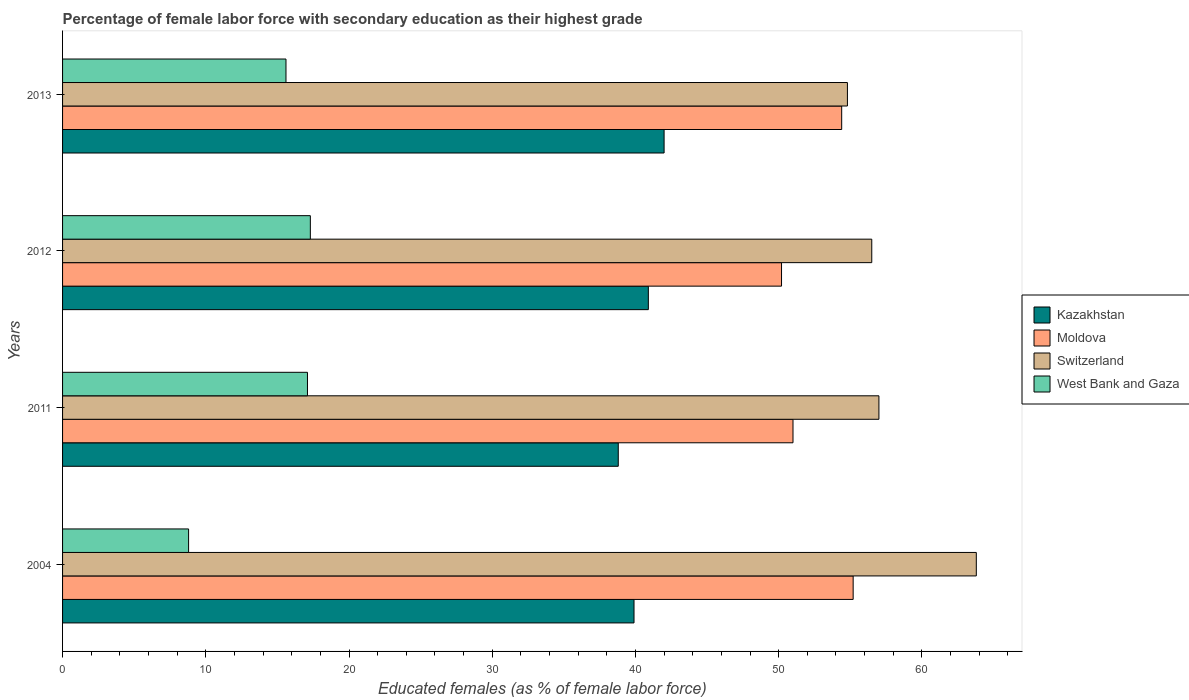What is the label of the 1st group of bars from the top?
Your answer should be compact. 2013. In how many cases, is the number of bars for a given year not equal to the number of legend labels?
Give a very brief answer. 0. What is the percentage of female labor force with secondary education in Moldova in 2004?
Ensure brevity in your answer.  55.2. Across all years, what is the maximum percentage of female labor force with secondary education in West Bank and Gaza?
Offer a very short reply. 17.3. Across all years, what is the minimum percentage of female labor force with secondary education in West Bank and Gaza?
Ensure brevity in your answer.  8.8. In which year was the percentage of female labor force with secondary education in Moldova maximum?
Give a very brief answer. 2004. What is the total percentage of female labor force with secondary education in West Bank and Gaza in the graph?
Keep it short and to the point. 58.8. What is the difference between the percentage of female labor force with secondary education in Moldova in 2004 and that in 2012?
Offer a terse response. 5. What is the difference between the percentage of female labor force with secondary education in Switzerland in 2004 and the percentage of female labor force with secondary education in Moldova in 2012?
Offer a terse response. 13.6. What is the average percentage of female labor force with secondary education in Moldova per year?
Give a very brief answer. 52.7. In the year 2012, what is the difference between the percentage of female labor force with secondary education in Switzerland and percentage of female labor force with secondary education in Kazakhstan?
Your answer should be compact. 15.6. In how many years, is the percentage of female labor force with secondary education in Kazakhstan greater than 4 %?
Make the answer very short. 4. What is the ratio of the percentage of female labor force with secondary education in Moldova in 2011 to that in 2012?
Your response must be concise. 1.02. Is the percentage of female labor force with secondary education in Kazakhstan in 2004 less than that in 2013?
Provide a short and direct response. Yes. What is the difference between the highest and the second highest percentage of female labor force with secondary education in Kazakhstan?
Ensure brevity in your answer.  1.1. What is the difference between the highest and the lowest percentage of female labor force with secondary education in West Bank and Gaza?
Your answer should be very brief. 8.5. Is it the case that in every year, the sum of the percentage of female labor force with secondary education in West Bank and Gaza and percentage of female labor force with secondary education in Kazakhstan is greater than the sum of percentage of female labor force with secondary education in Switzerland and percentage of female labor force with secondary education in Moldova?
Give a very brief answer. No. What does the 4th bar from the top in 2012 represents?
Offer a terse response. Kazakhstan. What does the 4th bar from the bottom in 2011 represents?
Provide a succinct answer. West Bank and Gaza. How many bars are there?
Your response must be concise. 16. How many years are there in the graph?
Your response must be concise. 4. Does the graph contain any zero values?
Provide a succinct answer. No. Does the graph contain grids?
Your response must be concise. No. Where does the legend appear in the graph?
Give a very brief answer. Center right. How many legend labels are there?
Provide a succinct answer. 4. How are the legend labels stacked?
Your answer should be very brief. Vertical. What is the title of the graph?
Offer a terse response. Percentage of female labor force with secondary education as their highest grade. What is the label or title of the X-axis?
Make the answer very short. Educated females (as % of female labor force). What is the Educated females (as % of female labor force) of Kazakhstan in 2004?
Your answer should be compact. 39.9. What is the Educated females (as % of female labor force) in Moldova in 2004?
Make the answer very short. 55.2. What is the Educated females (as % of female labor force) in Switzerland in 2004?
Your response must be concise. 63.8. What is the Educated females (as % of female labor force) in West Bank and Gaza in 2004?
Your answer should be compact. 8.8. What is the Educated females (as % of female labor force) in Kazakhstan in 2011?
Give a very brief answer. 38.8. What is the Educated females (as % of female labor force) of Switzerland in 2011?
Offer a terse response. 57. What is the Educated females (as % of female labor force) in West Bank and Gaza in 2011?
Provide a succinct answer. 17.1. What is the Educated females (as % of female labor force) in Kazakhstan in 2012?
Offer a very short reply. 40.9. What is the Educated females (as % of female labor force) in Moldova in 2012?
Give a very brief answer. 50.2. What is the Educated females (as % of female labor force) of Switzerland in 2012?
Ensure brevity in your answer.  56.5. What is the Educated females (as % of female labor force) in West Bank and Gaza in 2012?
Offer a terse response. 17.3. What is the Educated females (as % of female labor force) in Kazakhstan in 2013?
Your answer should be very brief. 42. What is the Educated females (as % of female labor force) of Moldova in 2013?
Offer a very short reply. 54.4. What is the Educated females (as % of female labor force) in Switzerland in 2013?
Your answer should be compact. 54.8. What is the Educated females (as % of female labor force) in West Bank and Gaza in 2013?
Ensure brevity in your answer.  15.6. Across all years, what is the maximum Educated females (as % of female labor force) in Moldova?
Offer a very short reply. 55.2. Across all years, what is the maximum Educated females (as % of female labor force) of Switzerland?
Offer a very short reply. 63.8. Across all years, what is the maximum Educated females (as % of female labor force) in West Bank and Gaza?
Offer a terse response. 17.3. Across all years, what is the minimum Educated females (as % of female labor force) in Kazakhstan?
Offer a terse response. 38.8. Across all years, what is the minimum Educated females (as % of female labor force) of Moldova?
Provide a short and direct response. 50.2. Across all years, what is the minimum Educated females (as % of female labor force) of Switzerland?
Your response must be concise. 54.8. Across all years, what is the minimum Educated females (as % of female labor force) of West Bank and Gaza?
Provide a succinct answer. 8.8. What is the total Educated females (as % of female labor force) in Kazakhstan in the graph?
Provide a short and direct response. 161.6. What is the total Educated females (as % of female labor force) of Moldova in the graph?
Your answer should be very brief. 210.8. What is the total Educated females (as % of female labor force) in Switzerland in the graph?
Your response must be concise. 232.1. What is the total Educated females (as % of female labor force) of West Bank and Gaza in the graph?
Your answer should be compact. 58.8. What is the difference between the Educated females (as % of female labor force) in Kazakhstan in 2004 and that in 2011?
Keep it short and to the point. 1.1. What is the difference between the Educated females (as % of female labor force) of Switzerland in 2004 and that in 2011?
Give a very brief answer. 6.8. What is the difference between the Educated females (as % of female labor force) of Moldova in 2004 and that in 2012?
Keep it short and to the point. 5. What is the difference between the Educated females (as % of female labor force) in Switzerland in 2004 and that in 2012?
Offer a terse response. 7.3. What is the difference between the Educated females (as % of female labor force) of Kazakhstan in 2004 and that in 2013?
Provide a succinct answer. -2.1. What is the difference between the Educated females (as % of female labor force) in Switzerland in 2004 and that in 2013?
Give a very brief answer. 9. What is the difference between the Educated females (as % of female labor force) in West Bank and Gaza in 2004 and that in 2013?
Offer a terse response. -6.8. What is the difference between the Educated females (as % of female labor force) in Kazakhstan in 2011 and that in 2012?
Provide a succinct answer. -2.1. What is the difference between the Educated females (as % of female labor force) of Moldova in 2011 and that in 2012?
Provide a succinct answer. 0.8. What is the difference between the Educated females (as % of female labor force) of Switzerland in 2011 and that in 2012?
Keep it short and to the point. 0.5. What is the difference between the Educated females (as % of female labor force) in West Bank and Gaza in 2011 and that in 2012?
Your answer should be very brief. -0.2. What is the difference between the Educated females (as % of female labor force) in Kazakhstan in 2012 and that in 2013?
Your answer should be compact. -1.1. What is the difference between the Educated females (as % of female labor force) in Moldova in 2012 and that in 2013?
Give a very brief answer. -4.2. What is the difference between the Educated females (as % of female labor force) of Switzerland in 2012 and that in 2013?
Provide a succinct answer. 1.7. What is the difference between the Educated females (as % of female labor force) of Kazakhstan in 2004 and the Educated females (as % of female labor force) of Moldova in 2011?
Offer a terse response. -11.1. What is the difference between the Educated females (as % of female labor force) of Kazakhstan in 2004 and the Educated females (as % of female labor force) of Switzerland in 2011?
Provide a short and direct response. -17.1. What is the difference between the Educated females (as % of female labor force) of Kazakhstan in 2004 and the Educated females (as % of female labor force) of West Bank and Gaza in 2011?
Offer a very short reply. 22.8. What is the difference between the Educated females (as % of female labor force) in Moldova in 2004 and the Educated females (as % of female labor force) in West Bank and Gaza in 2011?
Make the answer very short. 38.1. What is the difference between the Educated females (as % of female labor force) in Switzerland in 2004 and the Educated females (as % of female labor force) in West Bank and Gaza in 2011?
Make the answer very short. 46.7. What is the difference between the Educated females (as % of female labor force) in Kazakhstan in 2004 and the Educated females (as % of female labor force) in Moldova in 2012?
Offer a very short reply. -10.3. What is the difference between the Educated females (as % of female labor force) of Kazakhstan in 2004 and the Educated females (as % of female labor force) of Switzerland in 2012?
Provide a short and direct response. -16.6. What is the difference between the Educated females (as % of female labor force) of Kazakhstan in 2004 and the Educated females (as % of female labor force) of West Bank and Gaza in 2012?
Your response must be concise. 22.6. What is the difference between the Educated females (as % of female labor force) in Moldova in 2004 and the Educated females (as % of female labor force) in Switzerland in 2012?
Make the answer very short. -1.3. What is the difference between the Educated females (as % of female labor force) of Moldova in 2004 and the Educated females (as % of female labor force) of West Bank and Gaza in 2012?
Your answer should be compact. 37.9. What is the difference between the Educated females (as % of female labor force) of Switzerland in 2004 and the Educated females (as % of female labor force) of West Bank and Gaza in 2012?
Keep it short and to the point. 46.5. What is the difference between the Educated females (as % of female labor force) in Kazakhstan in 2004 and the Educated females (as % of female labor force) in Switzerland in 2013?
Offer a very short reply. -14.9. What is the difference between the Educated females (as % of female labor force) of Kazakhstan in 2004 and the Educated females (as % of female labor force) of West Bank and Gaza in 2013?
Offer a very short reply. 24.3. What is the difference between the Educated females (as % of female labor force) of Moldova in 2004 and the Educated females (as % of female labor force) of West Bank and Gaza in 2013?
Offer a terse response. 39.6. What is the difference between the Educated females (as % of female labor force) in Switzerland in 2004 and the Educated females (as % of female labor force) in West Bank and Gaza in 2013?
Provide a succinct answer. 48.2. What is the difference between the Educated females (as % of female labor force) of Kazakhstan in 2011 and the Educated females (as % of female labor force) of Moldova in 2012?
Your answer should be very brief. -11.4. What is the difference between the Educated females (as % of female labor force) in Kazakhstan in 2011 and the Educated females (as % of female labor force) in Switzerland in 2012?
Your response must be concise. -17.7. What is the difference between the Educated females (as % of female labor force) of Moldova in 2011 and the Educated females (as % of female labor force) of West Bank and Gaza in 2012?
Offer a terse response. 33.7. What is the difference between the Educated females (as % of female labor force) in Switzerland in 2011 and the Educated females (as % of female labor force) in West Bank and Gaza in 2012?
Offer a very short reply. 39.7. What is the difference between the Educated females (as % of female labor force) of Kazakhstan in 2011 and the Educated females (as % of female labor force) of Moldova in 2013?
Your answer should be very brief. -15.6. What is the difference between the Educated females (as % of female labor force) of Kazakhstan in 2011 and the Educated females (as % of female labor force) of Switzerland in 2013?
Provide a short and direct response. -16. What is the difference between the Educated females (as % of female labor force) of Kazakhstan in 2011 and the Educated females (as % of female labor force) of West Bank and Gaza in 2013?
Ensure brevity in your answer.  23.2. What is the difference between the Educated females (as % of female labor force) of Moldova in 2011 and the Educated females (as % of female labor force) of West Bank and Gaza in 2013?
Give a very brief answer. 35.4. What is the difference between the Educated females (as % of female labor force) in Switzerland in 2011 and the Educated females (as % of female labor force) in West Bank and Gaza in 2013?
Your response must be concise. 41.4. What is the difference between the Educated females (as % of female labor force) in Kazakhstan in 2012 and the Educated females (as % of female labor force) in Switzerland in 2013?
Your response must be concise. -13.9. What is the difference between the Educated females (as % of female labor force) of Kazakhstan in 2012 and the Educated females (as % of female labor force) of West Bank and Gaza in 2013?
Provide a short and direct response. 25.3. What is the difference between the Educated females (as % of female labor force) of Moldova in 2012 and the Educated females (as % of female labor force) of Switzerland in 2013?
Your answer should be very brief. -4.6. What is the difference between the Educated females (as % of female labor force) in Moldova in 2012 and the Educated females (as % of female labor force) in West Bank and Gaza in 2013?
Provide a short and direct response. 34.6. What is the difference between the Educated females (as % of female labor force) of Switzerland in 2012 and the Educated females (as % of female labor force) of West Bank and Gaza in 2013?
Keep it short and to the point. 40.9. What is the average Educated females (as % of female labor force) in Kazakhstan per year?
Your answer should be compact. 40.4. What is the average Educated females (as % of female labor force) of Moldova per year?
Provide a succinct answer. 52.7. What is the average Educated females (as % of female labor force) of Switzerland per year?
Your answer should be compact. 58.02. What is the average Educated females (as % of female labor force) in West Bank and Gaza per year?
Provide a short and direct response. 14.7. In the year 2004, what is the difference between the Educated females (as % of female labor force) of Kazakhstan and Educated females (as % of female labor force) of Moldova?
Your response must be concise. -15.3. In the year 2004, what is the difference between the Educated females (as % of female labor force) in Kazakhstan and Educated females (as % of female labor force) in Switzerland?
Offer a terse response. -23.9. In the year 2004, what is the difference between the Educated females (as % of female labor force) of Kazakhstan and Educated females (as % of female labor force) of West Bank and Gaza?
Offer a very short reply. 31.1. In the year 2004, what is the difference between the Educated females (as % of female labor force) of Moldova and Educated females (as % of female labor force) of Switzerland?
Provide a succinct answer. -8.6. In the year 2004, what is the difference between the Educated females (as % of female labor force) in Moldova and Educated females (as % of female labor force) in West Bank and Gaza?
Your answer should be very brief. 46.4. In the year 2011, what is the difference between the Educated females (as % of female labor force) in Kazakhstan and Educated females (as % of female labor force) in Moldova?
Provide a succinct answer. -12.2. In the year 2011, what is the difference between the Educated females (as % of female labor force) of Kazakhstan and Educated females (as % of female labor force) of Switzerland?
Your answer should be compact. -18.2. In the year 2011, what is the difference between the Educated females (as % of female labor force) of Kazakhstan and Educated females (as % of female labor force) of West Bank and Gaza?
Your response must be concise. 21.7. In the year 2011, what is the difference between the Educated females (as % of female labor force) in Moldova and Educated females (as % of female labor force) in West Bank and Gaza?
Your answer should be compact. 33.9. In the year 2011, what is the difference between the Educated females (as % of female labor force) in Switzerland and Educated females (as % of female labor force) in West Bank and Gaza?
Give a very brief answer. 39.9. In the year 2012, what is the difference between the Educated females (as % of female labor force) of Kazakhstan and Educated females (as % of female labor force) of Switzerland?
Make the answer very short. -15.6. In the year 2012, what is the difference between the Educated females (as % of female labor force) in Kazakhstan and Educated females (as % of female labor force) in West Bank and Gaza?
Provide a short and direct response. 23.6. In the year 2012, what is the difference between the Educated females (as % of female labor force) of Moldova and Educated females (as % of female labor force) of Switzerland?
Make the answer very short. -6.3. In the year 2012, what is the difference between the Educated females (as % of female labor force) in Moldova and Educated females (as % of female labor force) in West Bank and Gaza?
Your answer should be compact. 32.9. In the year 2012, what is the difference between the Educated females (as % of female labor force) in Switzerland and Educated females (as % of female labor force) in West Bank and Gaza?
Your answer should be compact. 39.2. In the year 2013, what is the difference between the Educated females (as % of female labor force) in Kazakhstan and Educated females (as % of female labor force) in West Bank and Gaza?
Make the answer very short. 26.4. In the year 2013, what is the difference between the Educated females (as % of female labor force) in Moldova and Educated females (as % of female labor force) in West Bank and Gaza?
Offer a terse response. 38.8. In the year 2013, what is the difference between the Educated females (as % of female labor force) of Switzerland and Educated females (as % of female labor force) of West Bank and Gaza?
Offer a terse response. 39.2. What is the ratio of the Educated females (as % of female labor force) in Kazakhstan in 2004 to that in 2011?
Provide a short and direct response. 1.03. What is the ratio of the Educated females (as % of female labor force) of Moldova in 2004 to that in 2011?
Ensure brevity in your answer.  1.08. What is the ratio of the Educated females (as % of female labor force) in Switzerland in 2004 to that in 2011?
Your answer should be compact. 1.12. What is the ratio of the Educated females (as % of female labor force) in West Bank and Gaza in 2004 to that in 2011?
Keep it short and to the point. 0.51. What is the ratio of the Educated females (as % of female labor force) in Kazakhstan in 2004 to that in 2012?
Your answer should be compact. 0.98. What is the ratio of the Educated females (as % of female labor force) of Moldova in 2004 to that in 2012?
Provide a succinct answer. 1.1. What is the ratio of the Educated females (as % of female labor force) in Switzerland in 2004 to that in 2012?
Your answer should be compact. 1.13. What is the ratio of the Educated females (as % of female labor force) in West Bank and Gaza in 2004 to that in 2012?
Your answer should be very brief. 0.51. What is the ratio of the Educated females (as % of female labor force) of Moldova in 2004 to that in 2013?
Provide a short and direct response. 1.01. What is the ratio of the Educated females (as % of female labor force) in Switzerland in 2004 to that in 2013?
Provide a succinct answer. 1.16. What is the ratio of the Educated females (as % of female labor force) in West Bank and Gaza in 2004 to that in 2013?
Your answer should be compact. 0.56. What is the ratio of the Educated females (as % of female labor force) in Kazakhstan in 2011 to that in 2012?
Make the answer very short. 0.95. What is the ratio of the Educated females (as % of female labor force) in Moldova in 2011 to that in 2012?
Offer a terse response. 1.02. What is the ratio of the Educated females (as % of female labor force) of Switzerland in 2011 to that in 2012?
Provide a succinct answer. 1.01. What is the ratio of the Educated females (as % of female labor force) in West Bank and Gaza in 2011 to that in 2012?
Keep it short and to the point. 0.99. What is the ratio of the Educated females (as % of female labor force) of Kazakhstan in 2011 to that in 2013?
Keep it short and to the point. 0.92. What is the ratio of the Educated females (as % of female labor force) of Moldova in 2011 to that in 2013?
Your answer should be very brief. 0.94. What is the ratio of the Educated females (as % of female labor force) of Switzerland in 2011 to that in 2013?
Provide a short and direct response. 1.04. What is the ratio of the Educated females (as % of female labor force) of West Bank and Gaza in 2011 to that in 2013?
Keep it short and to the point. 1.1. What is the ratio of the Educated females (as % of female labor force) in Kazakhstan in 2012 to that in 2013?
Your response must be concise. 0.97. What is the ratio of the Educated females (as % of female labor force) of Moldova in 2012 to that in 2013?
Ensure brevity in your answer.  0.92. What is the ratio of the Educated females (as % of female labor force) of Switzerland in 2012 to that in 2013?
Your answer should be compact. 1.03. What is the ratio of the Educated females (as % of female labor force) in West Bank and Gaza in 2012 to that in 2013?
Provide a succinct answer. 1.11. What is the difference between the highest and the second highest Educated females (as % of female labor force) in Kazakhstan?
Your answer should be very brief. 1.1. What is the difference between the highest and the lowest Educated females (as % of female labor force) of Moldova?
Offer a terse response. 5. What is the difference between the highest and the lowest Educated females (as % of female labor force) in Switzerland?
Your answer should be compact. 9. What is the difference between the highest and the lowest Educated females (as % of female labor force) in West Bank and Gaza?
Your response must be concise. 8.5. 